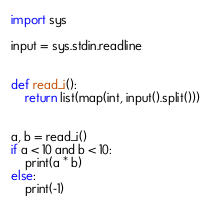<code> <loc_0><loc_0><loc_500><loc_500><_Python_>import sys

input = sys.stdin.readline


def read_i():
    return list(map(int, input().split()))


a, b = read_i()
if a < 10 and b < 10:
    print(a * b)
else:
    print(-1)</code> 